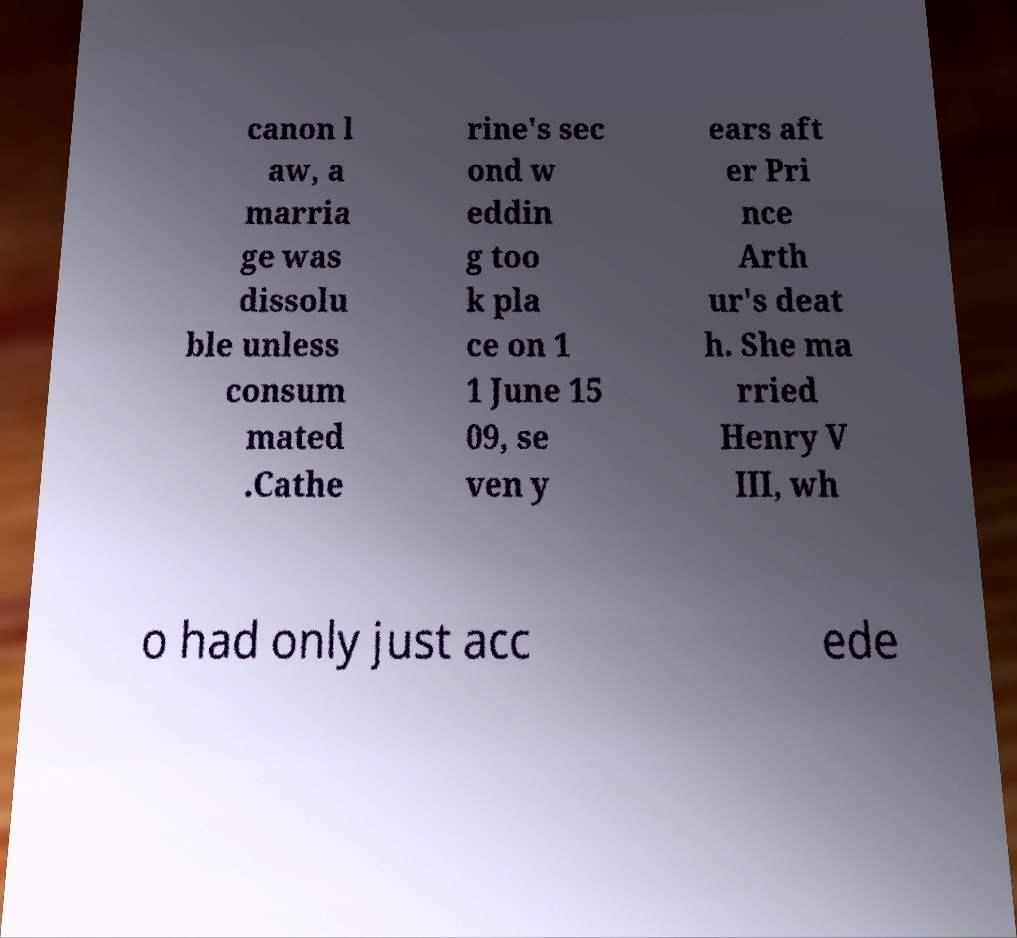Please read and relay the text visible in this image. What does it say? canon l aw, a marria ge was dissolu ble unless consum mated .Cathe rine's sec ond w eddin g too k pla ce on 1 1 June 15 09, se ven y ears aft er Pri nce Arth ur's deat h. She ma rried Henry V III, wh o had only just acc ede 